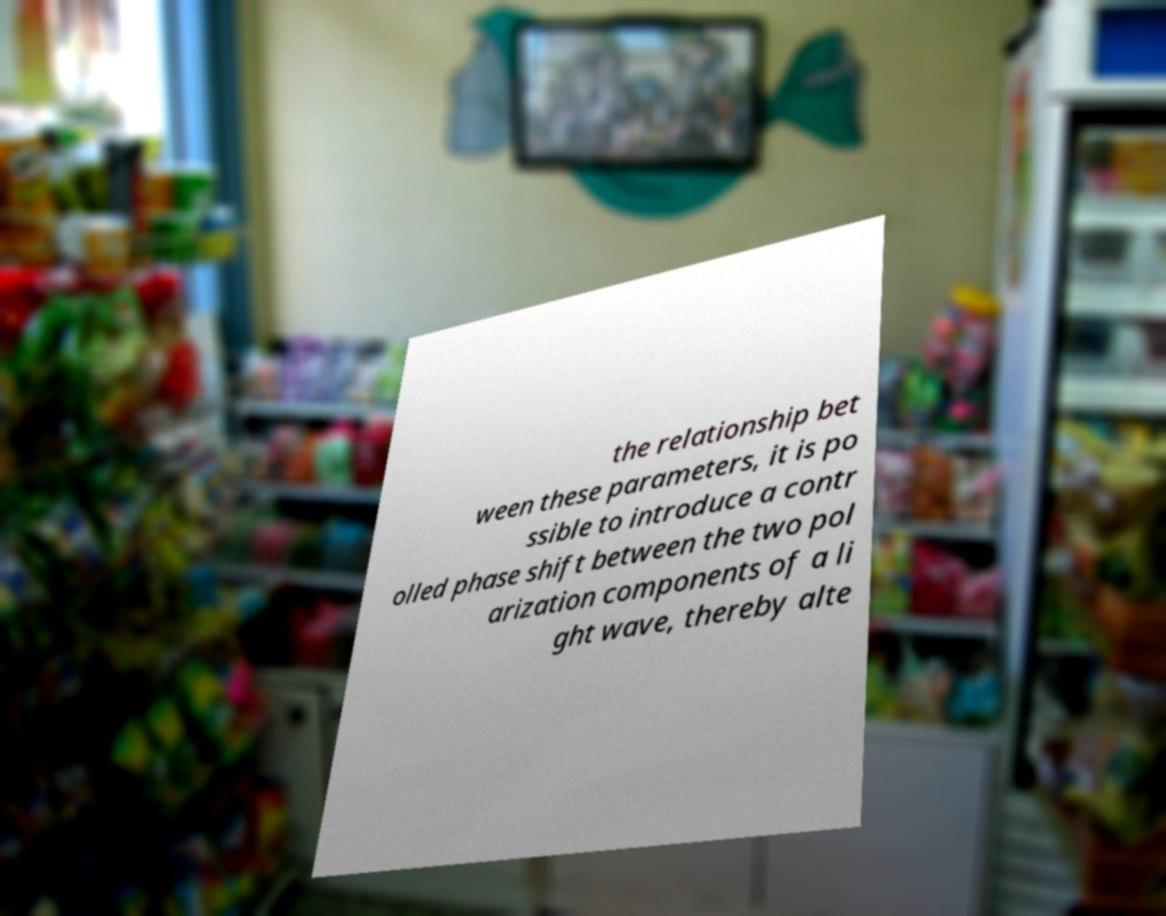For documentation purposes, I need the text within this image transcribed. Could you provide that? the relationship bet ween these parameters, it is po ssible to introduce a contr olled phase shift between the two pol arization components of a li ght wave, thereby alte 